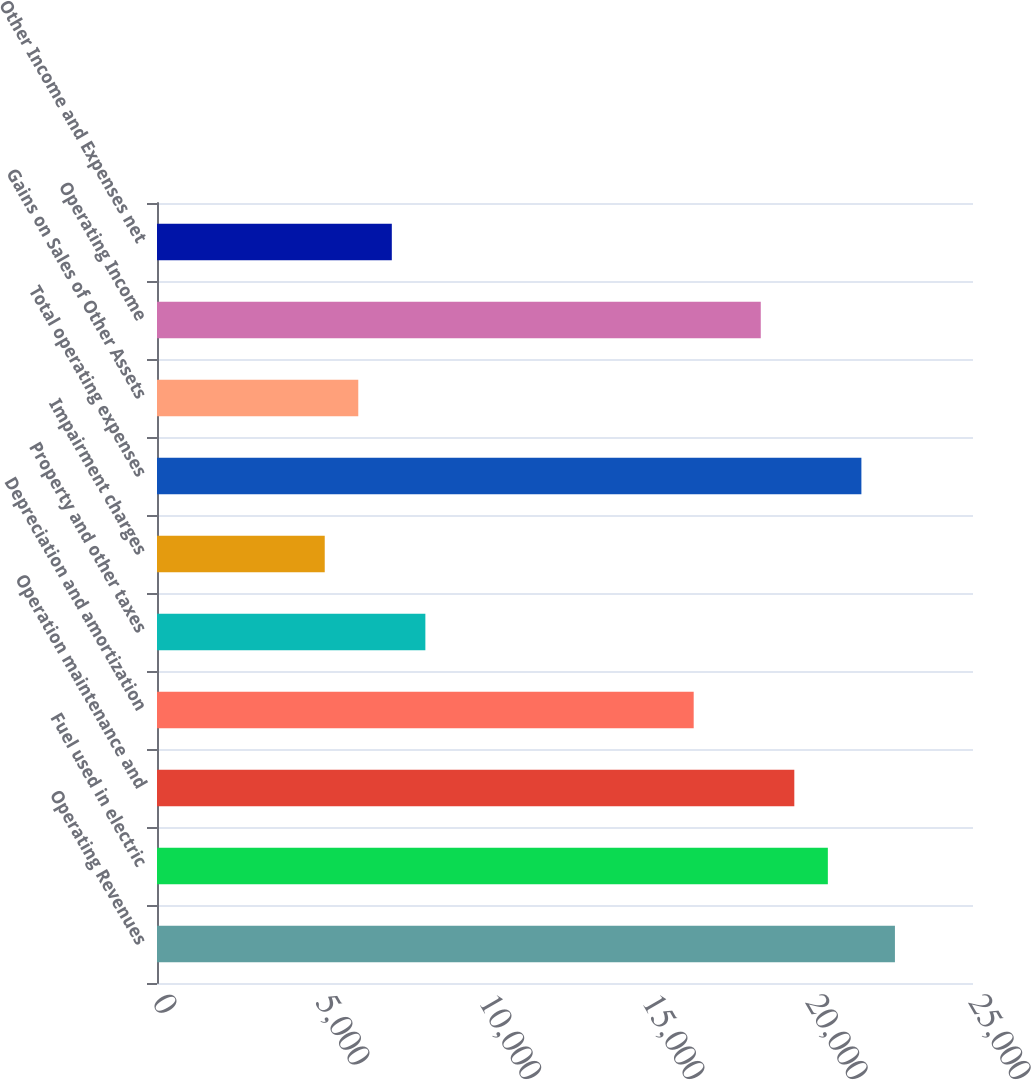Convert chart. <chart><loc_0><loc_0><loc_500><loc_500><bar_chart><fcel>Operating Revenues<fcel>Fuel used in electric<fcel>Operation maintenance and<fcel>Depreciation and amortization<fcel>Property and other taxes<fcel>Impairment charges<fcel>Total operating expenses<fcel>Gains on Sales of Other Assets<fcel>Operating Income<fcel>Other Income and Expenses net<nl><fcel>22608.2<fcel>20553<fcel>19525.4<fcel>16442.6<fcel>8221.8<fcel>5139<fcel>21580.6<fcel>6166.6<fcel>18497.8<fcel>7194.2<nl></chart> 